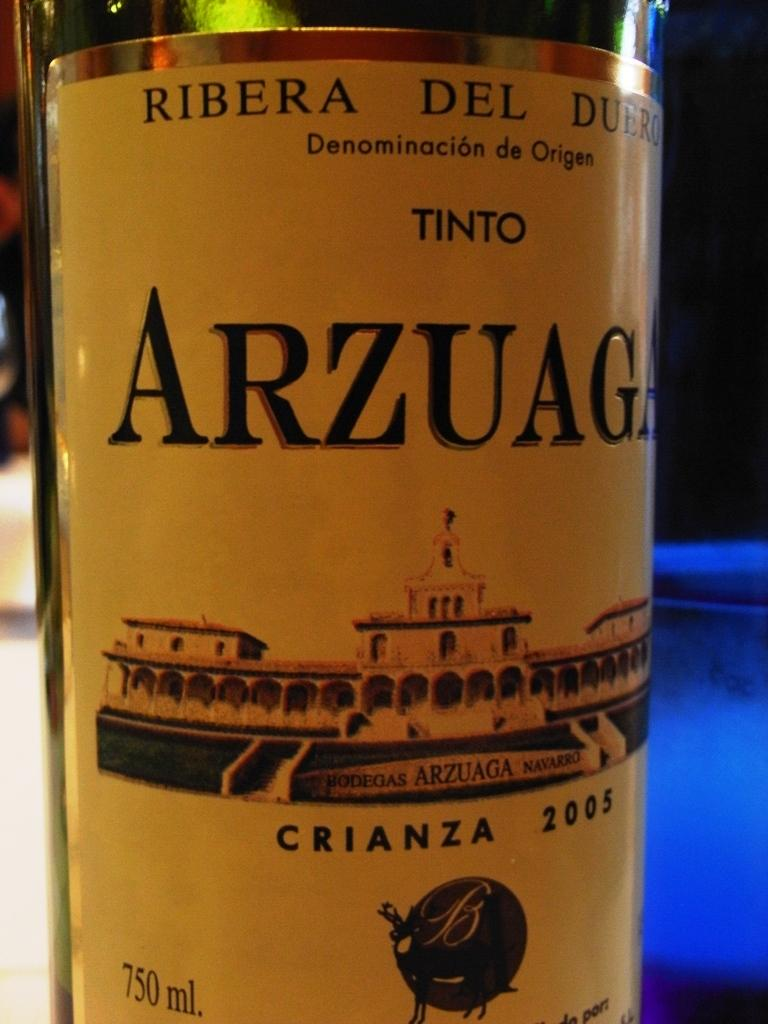Provide a one-sentence caption for the provided image. A bottle of Arzuaga from 2005 has a picture of a building on the label. 